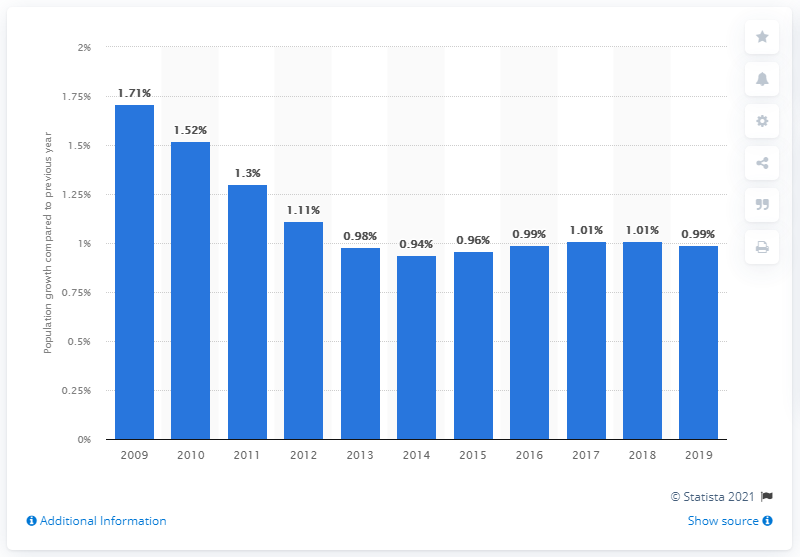Give some essential details in this illustration. The population of the Bahamas increased by 0.99% in 2019. 